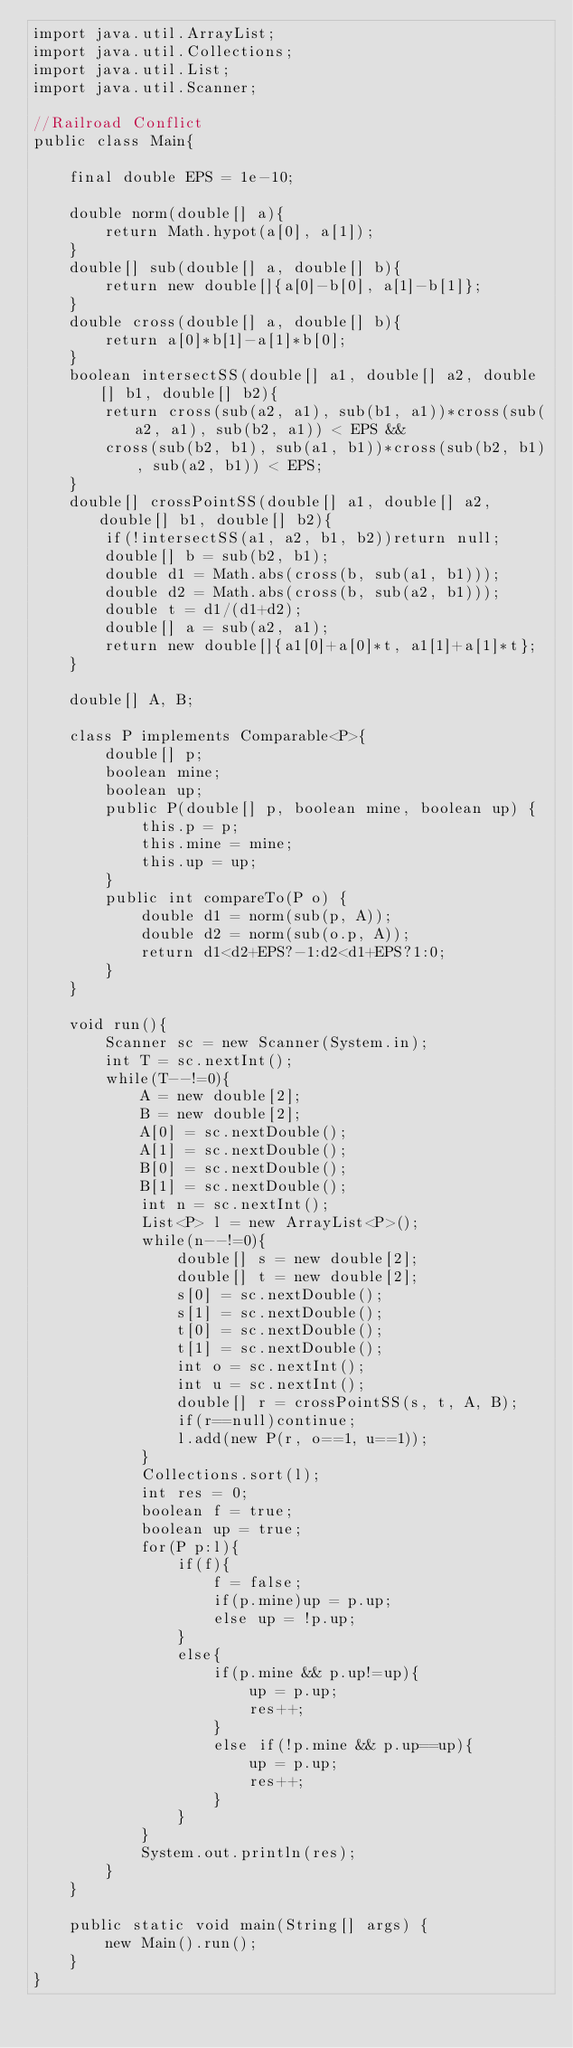Convert code to text. <code><loc_0><loc_0><loc_500><loc_500><_Java_>import java.util.ArrayList;
import java.util.Collections;
import java.util.List;
import java.util.Scanner;

//Railroad Conflict
public class Main{

	final double EPS = 1e-10;

	double norm(double[] a){
		return Math.hypot(a[0], a[1]);
	}
	double[] sub(double[] a, double[] b){
		return new double[]{a[0]-b[0], a[1]-b[1]};
	}
	double cross(double[] a, double[] b){
		return a[0]*b[1]-a[1]*b[0];
	}
	boolean intersectSS(double[] a1, double[] a2, double[] b1, double[] b2){
		return cross(sub(a2, a1), sub(b1, a1))*cross(sub(a2, a1), sub(b2, a1)) < EPS &&
		cross(sub(b2, b1), sub(a1, b1))*cross(sub(b2, b1), sub(a2, b1)) < EPS;
	}
	double[] crossPointSS(double[] a1, double[] a2, double[] b1, double[] b2){
		if(!intersectSS(a1, a2, b1, b2))return null;
		double[] b = sub(b2, b1);
		double d1 = Math.abs(cross(b, sub(a1, b1)));
		double d2 = Math.abs(cross(b, sub(a2, b1)));
		double t = d1/(d1+d2);
		double[] a = sub(a2, a1);
		return new double[]{a1[0]+a[0]*t, a1[1]+a[1]*t};
	}

	double[] A, B;

	class P implements Comparable<P>{
		double[] p;
		boolean mine;
		boolean up;
		public P(double[] p, boolean mine, boolean up) {
			this.p = p;
			this.mine = mine;
			this.up = up;
		}
		public int compareTo(P o) {
			double d1 = norm(sub(p, A));
			double d2 = norm(sub(o.p, A));
			return d1<d2+EPS?-1:d2<d1+EPS?1:0;
		}
	}

	void run(){
		Scanner sc = new Scanner(System.in);
		int T = sc.nextInt();
		while(T--!=0){
			A = new double[2];
			B = new double[2];
			A[0] = sc.nextDouble();
			A[1] = sc.nextDouble();
			B[0] = sc.nextDouble();
			B[1] = sc.nextDouble();
			int n = sc.nextInt();
			List<P> l = new ArrayList<P>();
			while(n--!=0){
				double[] s = new double[2];
				double[] t = new double[2];
				s[0] = sc.nextDouble();
				s[1] = sc.nextDouble();
				t[0] = sc.nextDouble();
				t[1] = sc.nextDouble();
				int o = sc.nextInt();
				int u = sc.nextInt();
				double[] r = crossPointSS(s, t, A, B);
				if(r==null)continue;
				l.add(new P(r, o==1, u==1));
			}
			Collections.sort(l);
			int res = 0;
			boolean f = true;
			boolean up = true;
			for(P p:l){
				if(f){
					f = false;
					if(p.mine)up = p.up;
					else up = !p.up;
				}
				else{
					if(p.mine && p.up!=up){
						up = p.up;
						res++;
					}
					else if(!p.mine && p.up==up){
						up = p.up;
						res++;
					}
				}
			}
			System.out.println(res);
		}
	}

	public static void main(String[] args) {
		new Main().run();
	}
}</code> 